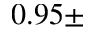<formula> <loc_0><loc_0><loc_500><loc_500>0 . 9 5 \pm</formula> 